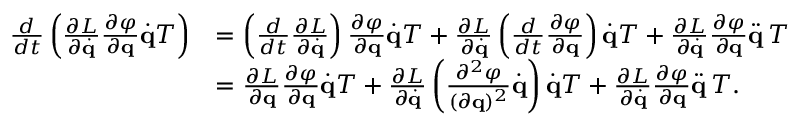<formula> <loc_0><loc_0><loc_500><loc_500>{ \begin{array} { r l } { { \frac { d } { d t } } \left ( { \frac { \partial L } { \partial { \dot { q } } } } { \frac { \partial \varphi } { \partial q } } { \dot { q } } T \right ) } & { = \left ( { \frac { d } { d t } } { \frac { \partial L } { \partial { \dot { q } } } } \right ) { \frac { \partial \varphi } { \partial q } } { \dot { q } } T + { \frac { \partial L } { \partial { \dot { q } } } } \left ( { \frac { d } { d t } } { \frac { \partial \varphi } { \partial q } } \right ) { \dot { q } } T + { \frac { \partial L } { \partial { \dot { q } } } } { \frac { \partial \varphi } { \partial q } } { \ddot { q } } \, T } \\ & { = { \frac { \partial L } { \partial q } } { \frac { \partial \varphi } { \partial q } } { \dot { q } } T + { \frac { \partial L } { \partial { \dot { q } } } } \left ( { \frac { \partial ^ { 2 } \varphi } { ( \partial q ) ^ { 2 } } } { \dot { q } } \right ) { \dot { q } } T + { \frac { \partial L } { \partial { \dot { q } } } } { \frac { \partial \varphi } { \partial q } } { \ddot { q } } \, T . } \end{array} }</formula> 